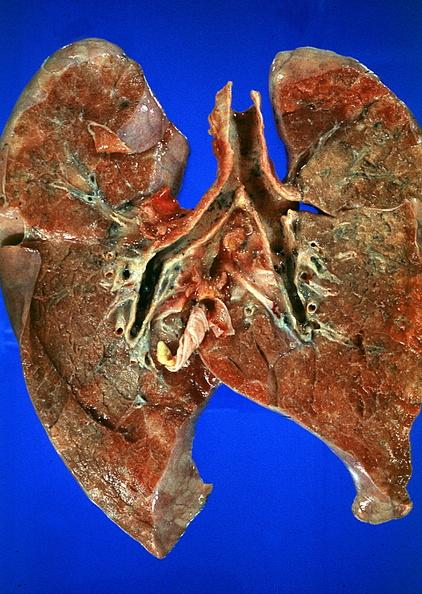what is present?
Answer the question using a single word or phrase. Respiratory 